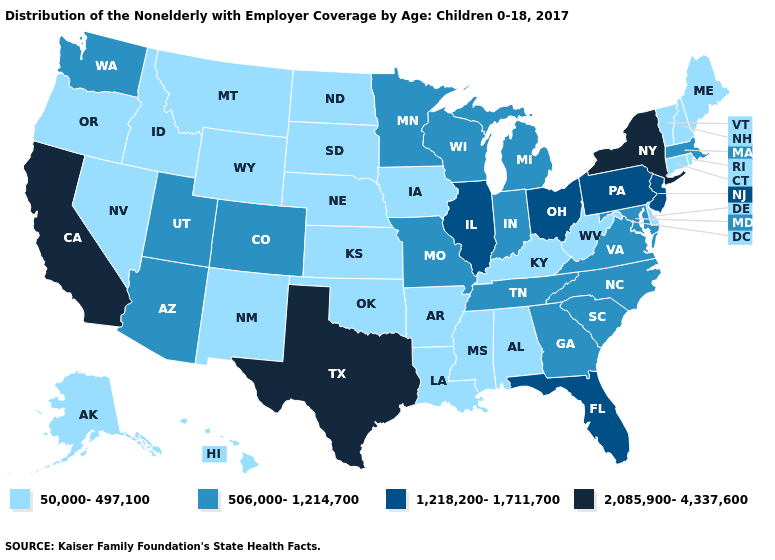What is the value of New Hampshire?
Keep it brief. 50,000-497,100. Among the states that border Delaware , which have the highest value?
Short answer required. New Jersey, Pennsylvania. What is the value of South Dakota?
Short answer required. 50,000-497,100. Does Ohio have the lowest value in the MidWest?
Quick response, please. No. Among the states that border Oklahoma , does Texas have the highest value?
Short answer required. Yes. What is the value of Maryland?
Short answer required. 506,000-1,214,700. Does the map have missing data?
Write a very short answer. No. Name the states that have a value in the range 2,085,900-4,337,600?
Short answer required. California, New York, Texas. What is the highest value in states that border Iowa?
Give a very brief answer. 1,218,200-1,711,700. Does Nevada have the highest value in the USA?
Concise answer only. No. Name the states that have a value in the range 506,000-1,214,700?
Give a very brief answer. Arizona, Colorado, Georgia, Indiana, Maryland, Massachusetts, Michigan, Minnesota, Missouri, North Carolina, South Carolina, Tennessee, Utah, Virginia, Washington, Wisconsin. What is the value of Utah?
Write a very short answer. 506,000-1,214,700. What is the value of Utah?
Short answer required. 506,000-1,214,700. Which states have the lowest value in the USA?
Concise answer only. Alabama, Alaska, Arkansas, Connecticut, Delaware, Hawaii, Idaho, Iowa, Kansas, Kentucky, Louisiana, Maine, Mississippi, Montana, Nebraska, Nevada, New Hampshire, New Mexico, North Dakota, Oklahoma, Oregon, Rhode Island, South Dakota, Vermont, West Virginia, Wyoming. Is the legend a continuous bar?
Be succinct. No. 